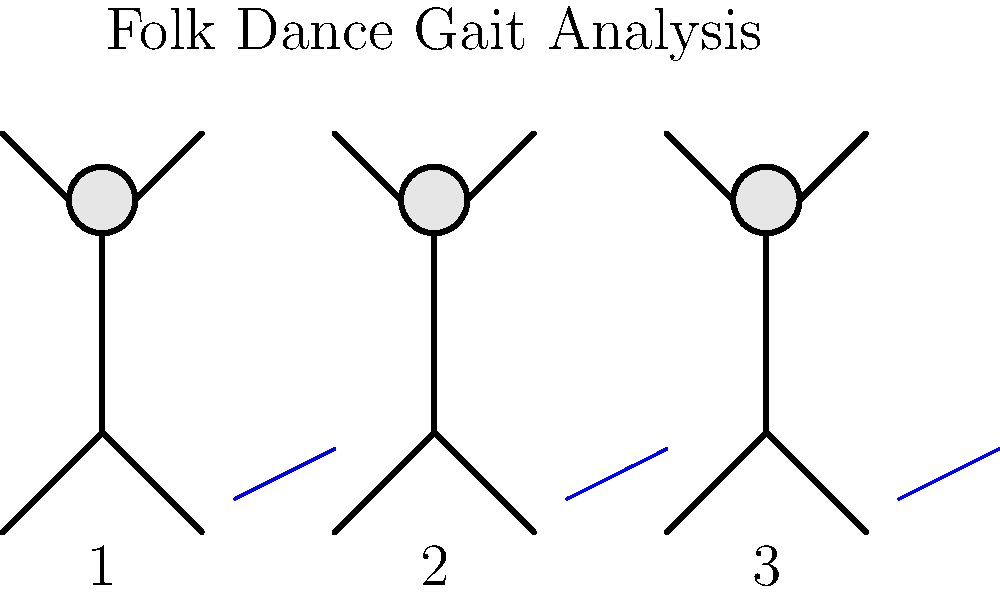In the context of folk dance biomechanics, which phase of the gait cycle is likely represented by stick figure 2 in the diagram, and how does this relate to the rhythmic patterns typically found in folk music? To answer this question, let's analyze the stick figure diagram and relate it to gait cycle phases and folk music rhythms:

1. Gait cycle phases: The gait cycle consists of two main phases - stance and swing.

2. Analyzing stick figure 2:
   - The figure appears to be in a mid-step position
   - Both legs are spread apart
   - The arms are raised, suggesting movement

3. Identifying the gait phase:
   - This position likely represents the mid-stance phase of the gait cycle
   - Mid-stance occurs when the body's center of mass is directly over the supporting limb

4. Relating to folk music rhythms:
   - Folk music often features strong, regular beats
   - The mid-stance phase in dancing would typically coincide with these strong beats
   - Dancers often emphasize this phase by adding a slight bounce or lift

5. Folk dance characteristics:
   - Many folk dances involve repetitive stepping patterns
   - These patterns often align with the music's rhythmic structure
   - The mid-stance phase allows dancers to accentuate the beat and prepare for the next step

Therefore, stick figure 2 likely represents the mid-stance phase of the gait cycle, which in folk dancing often aligns with the strong beats of the music, allowing dancers to emphasize the rhythm and prepare for subsequent movements.
Answer: Mid-stance phase 